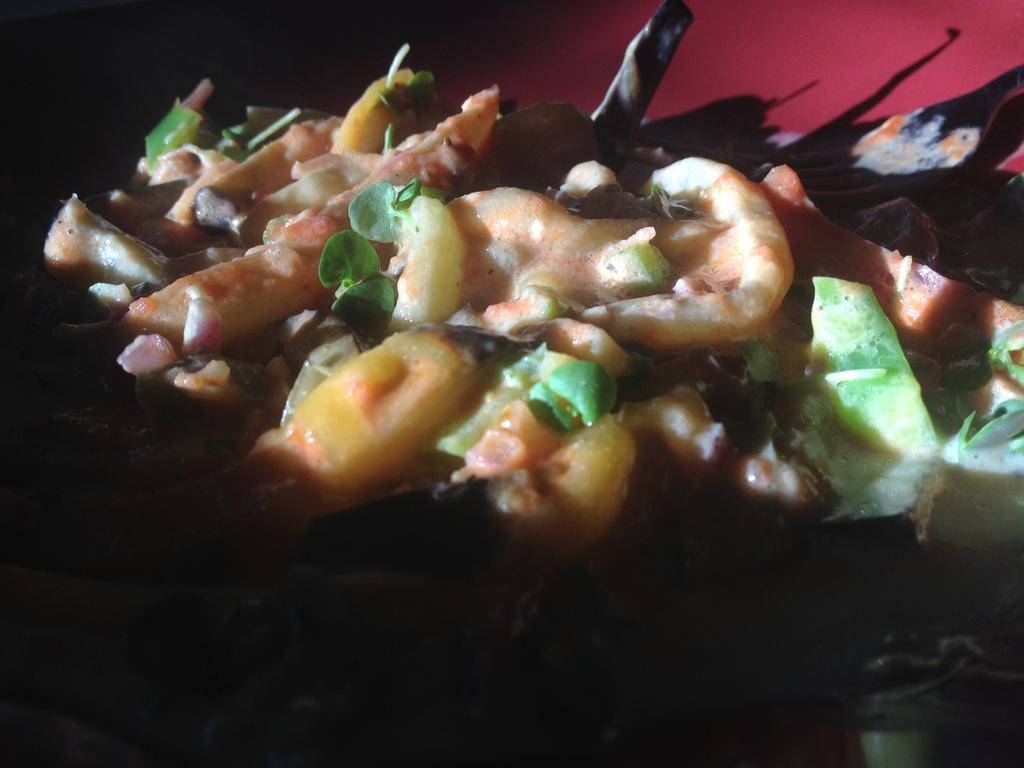Please provide a concise description of this image. In this image we can see the food item in the plate. 